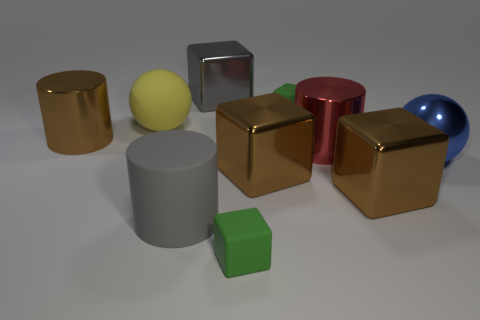There is a thing that is the same color as the rubber cylinder; what is its size?
Provide a short and direct response. Large. What shape is the metal object that is the same color as the matte cylinder?
Offer a terse response. Cube. The green object that is behind the big sphere that is left of the large gray cube is what shape?
Your answer should be very brief. Cube. Are there more big brown shiny blocks that are behind the big gray cylinder than large red objects?
Your answer should be very brief. Yes. There is a tiny object that is behind the large red metallic thing; does it have the same shape as the gray metal thing?
Your answer should be very brief. Yes. Is there a large gray object of the same shape as the yellow rubber object?
Your response must be concise. No. What number of objects are either large blocks that are behind the blue ball or large balls?
Your answer should be compact. 3. Is the number of red shiny cylinders greater than the number of shiny blocks?
Provide a short and direct response. No. Are there any shiny balls of the same size as the yellow object?
Make the answer very short. Yes. What number of things are either brown objects that are on the right side of the gray cube or large gray objects behind the big shiny ball?
Provide a short and direct response. 3. 